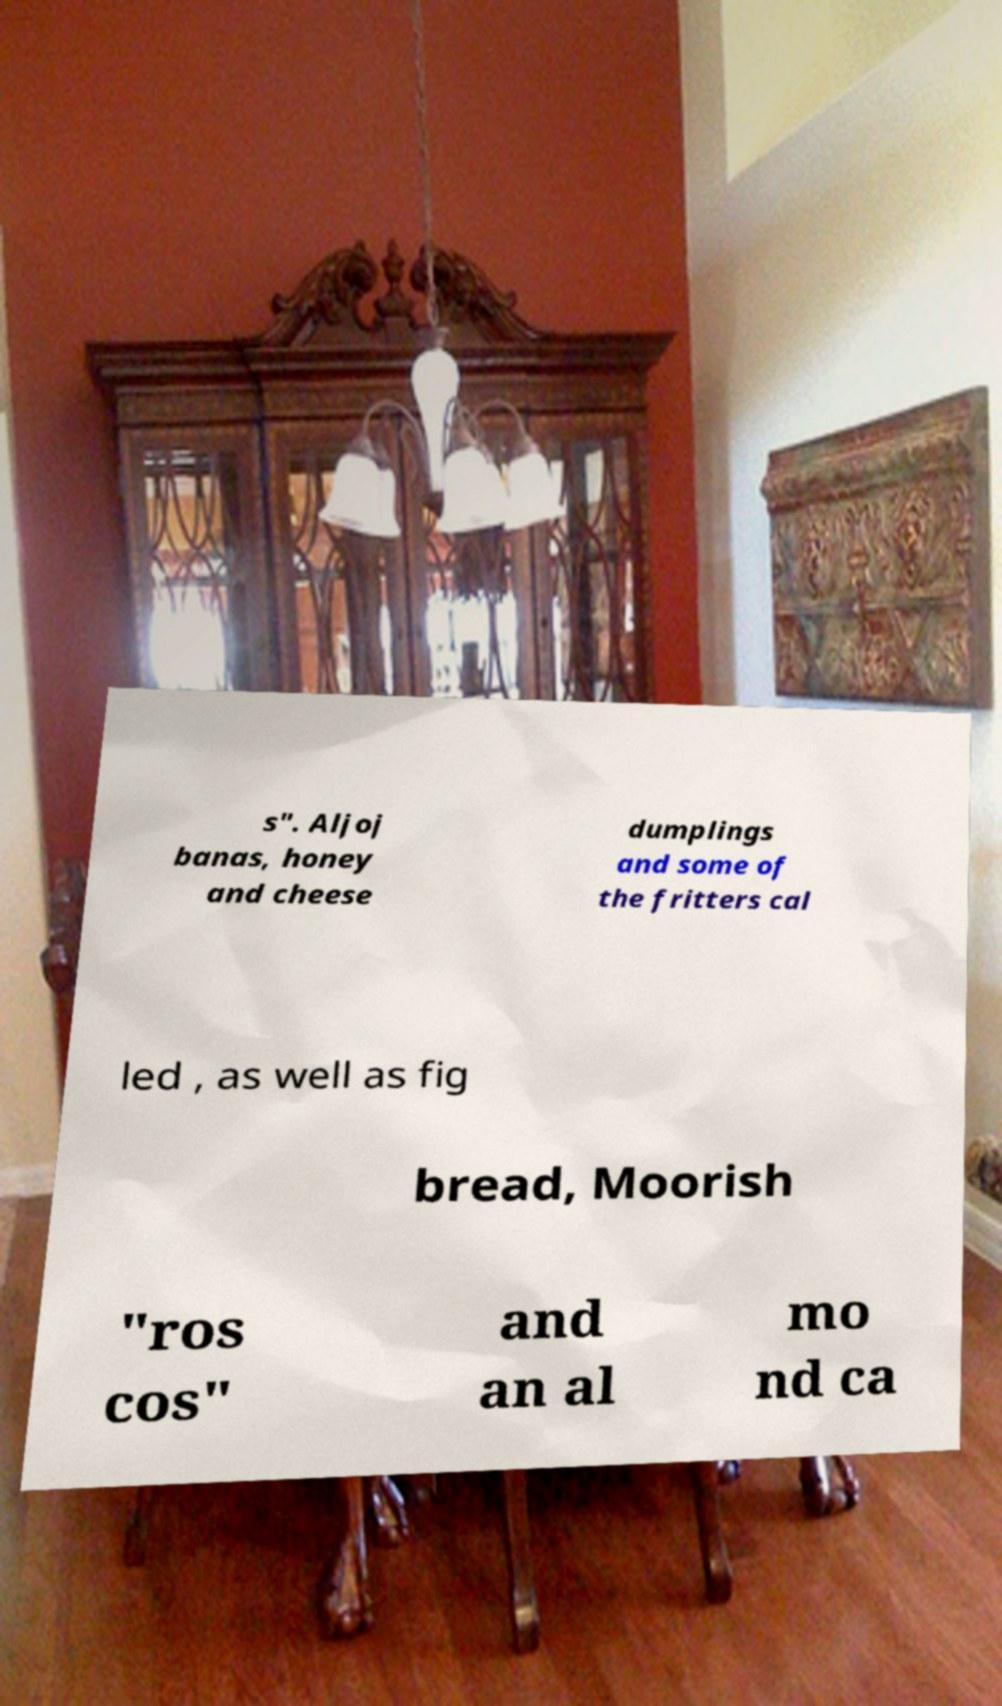What messages or text are displayed in this image? I need them in a readable, typed format. s". Aljoj banas, honey and cheese dumplings and some of the fritters cal led , as well as fig bread, Moorish "ros cos" and an al mo nd ca 